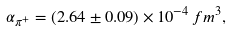<formula> <loc_0><loc_0><loc_500><loc_500>\alpha _ { \pi ^ { + } } = ( 2 . 6 4 \pm 0 . 0 9 ) \times 1 0 ^ { - 4 } \, f m ^ { 3 } ,</formula> 